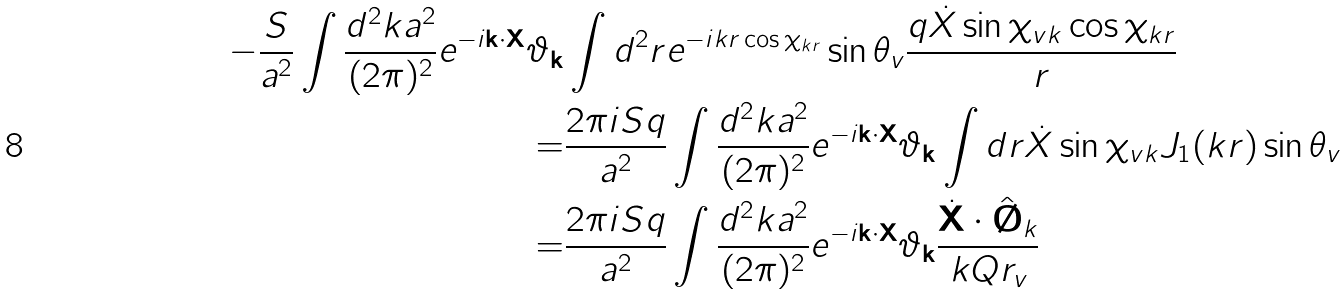Convert formula to latex. <formula><loc_0><loc_0><loc_500><loc_500>- \frac { S } { a ^ { 2 } } \int \frac { d ^ { 2 } k a ^ { 2 } } { ( 2 \pi ) ^ { 2 } } e ^ { - i \mathbf k \cdot \mathbf X } \vartheta _ { \mathbf k } & \int d ^ { 2 } r e ^ { - i k r \cos \chi _ { k r } } \sin \theta _ { v } \frac { q \dot { X } \sin \chi _ { v k } \cos \chi _ { k r } } { r } \\ = & \frac { 2 \pi i S q } { a ^ { 2 } } \int \frac { d ^ { 2 } k a ^ { 2 } } { ( 2 \pi ) ^ { 2 } } e ^ { - i \mathbf k \cdot \mathbf X } \vartheta _ { \mathbf k } \int d r \dot { X } \sin \chi _ { v k } J _ { 1 } ( k r ) \sin \theta _ { v } \\ = & \frac { 2 \pi i S q } { a ^ { 2 } } \int \frac { d ^ { 2 } k a ^ { 2 } } { ( 2 \pi ) ^ { 2 } } e ^ { - i \mathbf k \cdot \mathbf X } \vartheta _ { \mathbf k } \frac { \dot { \mathbf X } \cdot \hat { \mathbf \chi } _ { k } } { k Q r _ { v } }</formula> 